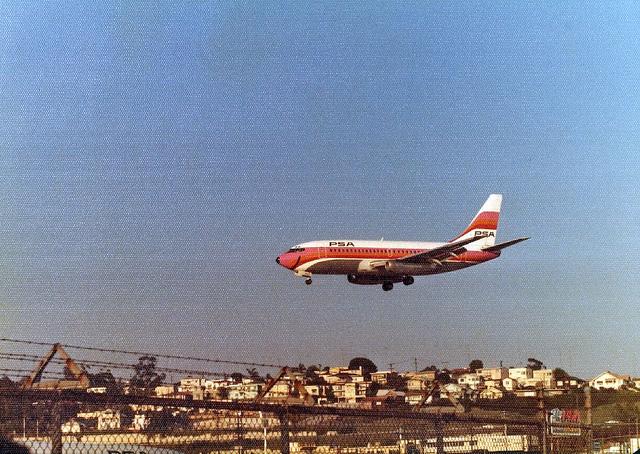Is the plane low to the ground?
Short answer required. Yes. Is this a rocket ship?
Concise answer only. No. Is this a passenger plane?
Quick response, please. Yes. 